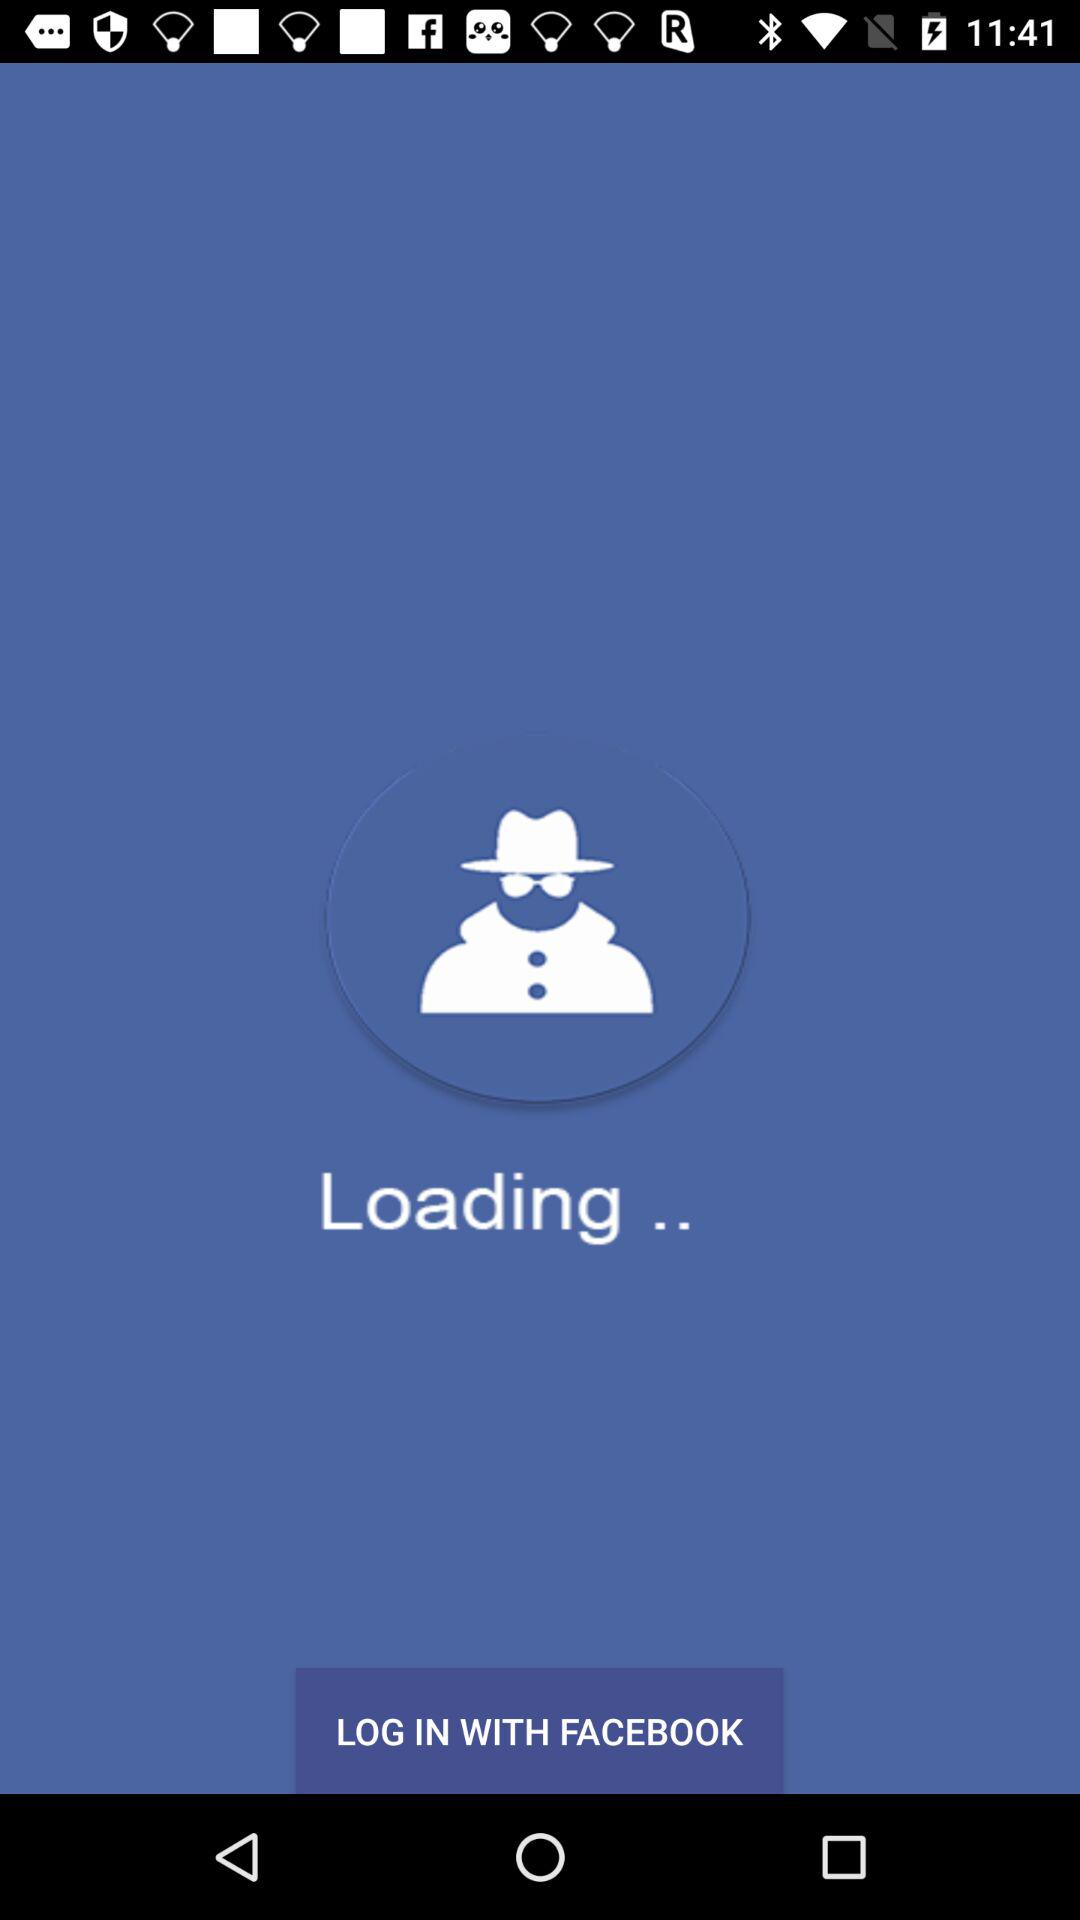Through what application can we log in? You can log in through "FACEBOOK". 